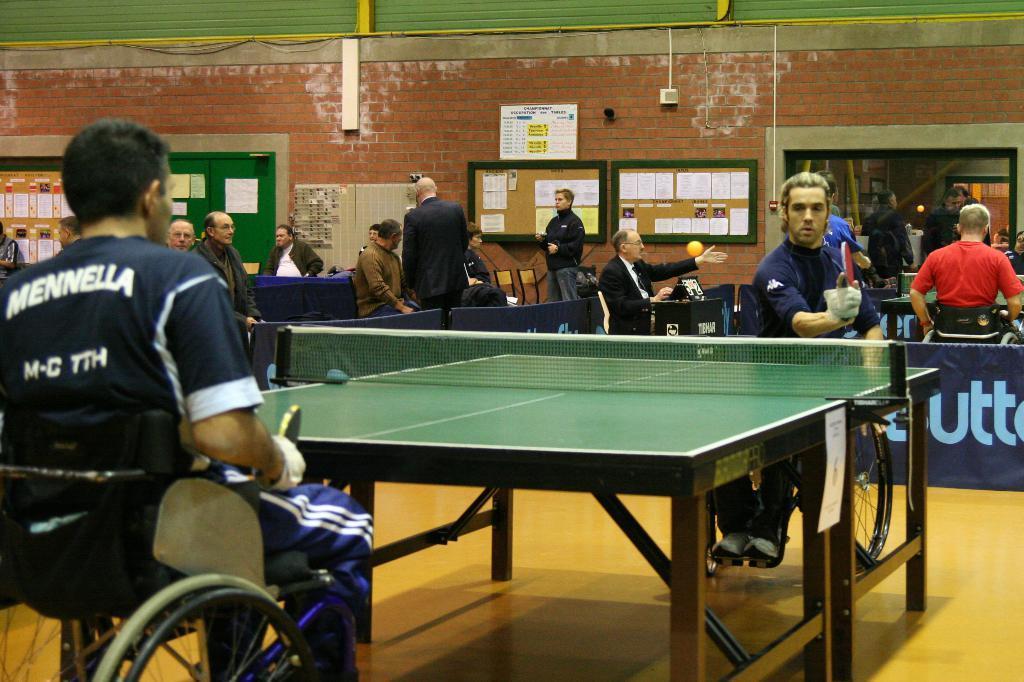Describe this image in one or two sentences. In picture there is a stadium in which many people are sitting on a wheelchair and playing table tennis game there are bats in there hands there are tables between them on the wall there are some boards on the boards there are some papers there are many chairs in the room there are banners there is some text. 